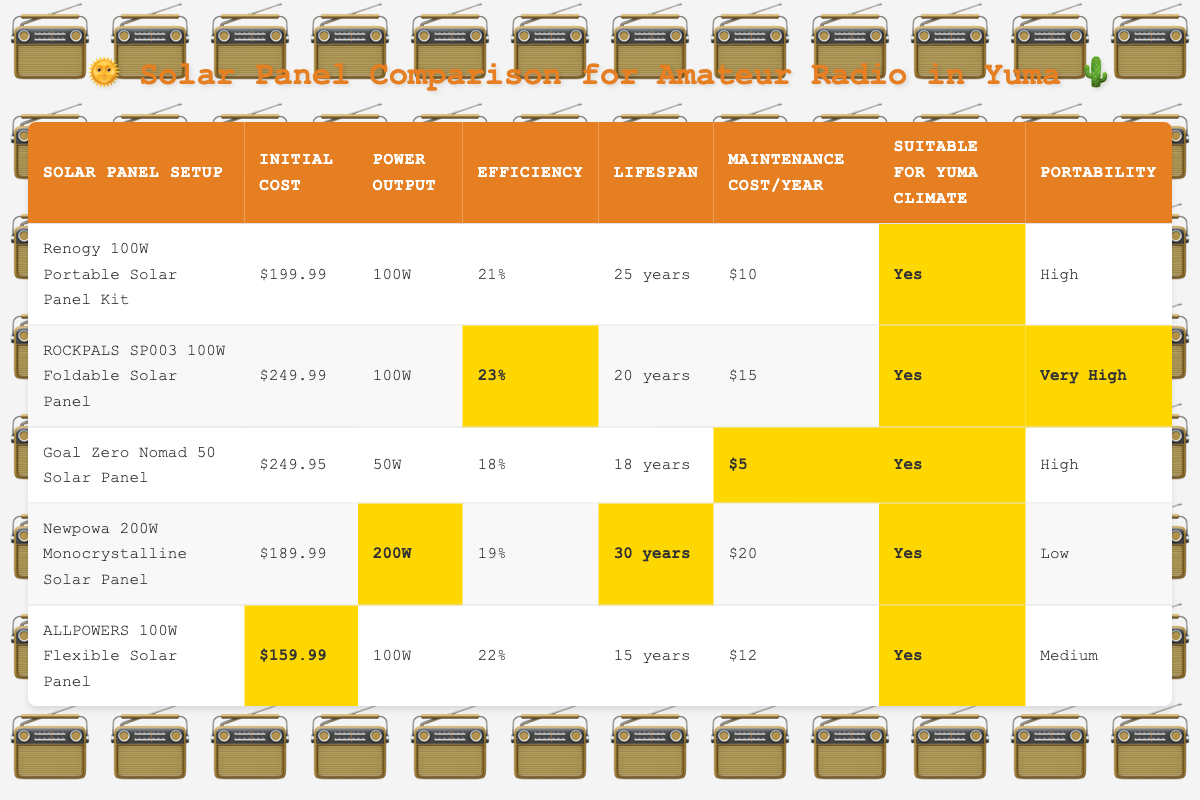What is the most affordable solar panel setup? The lowest initial cost among the listed setups is $159.99 for the ALLPOWERS 100W Flexible Solar Panel.
Answer: $159.99 What is the power output of the Renogy 100W Portable Solar Panel Kit? The Renogy 100W Portable Solar Panel Kit has a power output of 100W as specified in the table.
Answer: 100W Which solar panel setup has the highest efficiency? The highest efficiency is 23%, which belongs to the ROCKPALS SP003 100W Foldable Solar Panel.
Answer: 23% What is the average maintenance cost per year of all the solar panel setups? The maintenance costs are $10, $15, $5, $20, and $12. Summing these gives $62. Dividing by 5 panels, the average is $62/5 = $12.40.
Answer: $12.40 How many solar panel setups have a lifespan of over 25 years? The Newpowa 200W Monocrystalline Solar Panel has a lifespan of 30 years, and the Renogy 100W Portable Solar Panel Kit has a lifespan of 25 years. Thus, there are 2 setups with a lifespan of over 25 years.
Answer: 2 Is the Goal Zero Nomad 50 Solar Panel suitable for Yuma climate? Yes, according to the table, the Goal Zero Nomad 50 Solar Panel is marked as suitable for Yuma climate.
Answer: Yes Which solar panel setup offers the best power output relative to its initial cost? To find this, we compare the power output per dollar for each setup. The Newpowa 200W Monocrystalline Solar Panel offers 200W for $189.99, so it gives approximately 1.05W/$, which is the highest ratio among all.
Answer: Newpowa 200W Monocrystalline Solar Panel Which solar panel has the lowest efficiency and what is that efficiency? The Goal Zero Nomad 50 Solar Panel has the lowest efficiency at 18%.
Answer: 18% How does the maintenance cost of the ROCKPALS SP003 compare to the ALLPOWERS 100W? The ROCKPALS SP003 has a maintenance cost of $15 per year, while the ALLPOWERS 100W has a maintenance cost of $12 per year. Therefore, ROCKPALS is $3 more expensive in maintenance costs.
Answer: $3 more expensive 